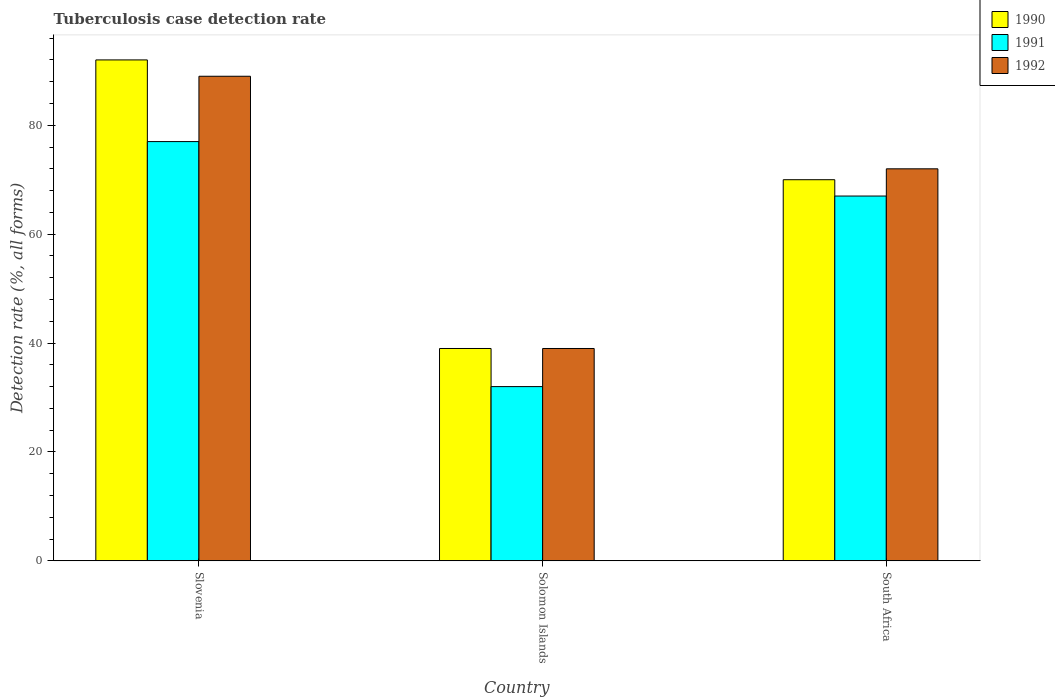How many groups of bars are there?
Offer a very short reply. 3. Are the number of bars per tick equal to the number of legend labels?
Provide a succinct answer. Yes. Are the number of bars on each tick of the X-axis equal?
Keep it short and to the point. Yes. How many bars are there on the 3rd tick from the right?
Your answer should be compact. 3. What is the label of the 3rd group of bars from the left?
Ensure brevity in your answer.  South Africa. In how many cases, is the number of bars for a given country not equal to the number of legend labels?
Give a very brief answer. 0. What is the tuberculosis case detection rate in in 1992 in Solomon Islands?
Offer a very short reply. 39. Across all countries, what is the maximum tuberculosis case detection rate in in 1992?
Give a very brief answer. 89. In which country was the tuberculosis case detection rate in in 1992 maximum?
Provide a succinct answer. Slovenia. In which country was the tuberculosis case detection rate in in 1992 minimum?
Provide a short and direct response. Solomon Islands. What is the total tuberculosis case detection rate in in 1991 in the graph?
Your response must be concise. 176. What is the difference between the tuberculosis case detection rate in in 1992 in Solomon Islands and that in South Africa?
Give a very brief answer. -33. What is the difference between the tuberculosis case detection rate in of/in 1990 and tuberculosis case detection rate in of/in 1992 in Slovenia?
Your answer should be compact. 3. What is the ratio of the tuberculosis case detection rate in in 1992 in Slovenia to that in South Africa?
Provide a succinct answer. 1.24. Is the tuberculosis case detection rate in in 1992 in Slovenia less than that in South Africa?
Offer a very short reply. No. What is the difference between the highest and the second highest tuberculosis case detection rate in in 1991?
Your answer should be very brief. -35. What does the 2nd bar from the left in Slovenia represents?
Provide a short and direct response. 1991. What does the 2nd bar from the right in South Africa represents?
Ensure brevity in your answer.  1991. Is it the case that in every country, the sum of the tuberculosis case detection rate in in 1991 and tuberculosis case detection rate in in 1990 is greater than the tuberculosis case detection rate in in 1992?
Offer a terse response. Yes. Are all the bars in the graph horizontal?
Offer a very short reply. No. Are the values on the major ticks of Y-axis written in scientific E-notation?
Offer a terse response. No. Does the graph contain grids?
Offer a very short reply. No. How many legend labels are there?
Your answer should be compact. 3. What is the title of the graph?
Offer a very short reply. Tuberculosis case detection rate. What is the label or title of the Y-axis?
Keep it short and to the point. Detection rate (%, all forms). What is the Detection rate (%, all forms) in 1990 in Slovenia?
Offer a terse response. 92. What is the Detection rate (%, all forms) of 1991 in Slovenia?
Offer a very short reply. 77. What is the Detection rate (%, all forms) of 1992 in Slovenia?
Your answer should be very brief. 89. What is the Detection rate (%, all forms) in 1990 in Solomon Islands?
Keep it short and to the point. 39. What is the Detection rate (%, all forms) of 1991 in Solomon Islands?
Your response must be concise. 32. What is the Detection rate (%, all forms) in 1990 in South Africa?
Your answer should be compact. 70. Across all countries, what is the maximum Detection rate (%, all forms) of 1990?
Keep it short and to the point. 92. Across all countries, what is the maximum Detection rate (%, all forms) of 1992?
Offer a very short reply. 89. Across all countries, what is the minimum Detection rate (%, all forms) in 1992?
Your answer should be compact. 39. What is the total Detection rate (%, all forms) of 1990 in the graph?
Keep it short and to the point. 201. What is the total Detection rate (%, all forms) of 1991 in the graph?
Make the answer very short. 176. What is the difference between the Detection rate (%, all forms) in 1991 in Slovenia and that in Solomon Islands?
Your answer should be compact. 45. What is the difference between the Detection rate (%, all forms) in 1992 in Slovenia and that in Solomon Islands?
Keep it short and to the point. 50. What is the difference between the Detection rate (%, all forms) in 1990 in Slovenia and that in South Africa?
Your response must be concise. 22. What is the difference between the Detection rate (%, all forms) of 1991 in Slovenia and that in South Africa?
Offer a terse response. 10. What is the difference between the Detection rate (%, all forms) in 1990 in Solomon Islands and that in South Africa?
Your response must be concise. -31. What is the difference between the Detection rate (%, all forms) in 1991 in Solomon Islands and that in South Africa?
Your answer should be compact. -35. What is the difference between the Detection rate (%, all forms) of 1992 in Solomon Islands and that in South Africa?
Give a very brief answer. -33. What is the difference between the Detection rate (%, all forms) in 1990 in Slovenia and the Detection rate (%, all forms) in 1991 in Solomon Islands?
Provide a succinct answer. 60. What is the difference between the Detection rate (%, all forms) in 1990 in Slovenia and the Detection rate (%, all forms) in 1991 in South Africa?
Give a very brief answer. 25. What is the difference between the Detection rate (%, all forms) in 1990 in Solomon Islands and the Detection rate (%, all forms) in 1991 in South Africa?
Your response must be concise. -28. What is the difference between the Detection rate (%, all forms) in 1990 in Solomon Islands and the Detection rate (%, all forms) in 1992 in South Africa?
Offer a very short reply. -33. What is the average Detection rate (%, all forms) of 1990 per country?
Give a very brief answer. 67. What is the average Detection rate (%, all forms) of 1991 per country?
Provide a short and direct response. 58.67. What is the average Detection rate (%, all forms) in 1992 per country?
Offer a very short reply. 66.67. What is the difference between the Detection rate (%, all forms) of 1990 and Detection rate (%, all forms) of 1991 in Slovenia?
Provide a succinct answer. 15. What is the difference between the Detection rate (%, all forms) in 1991 and Detection rate (%, all forms) in 1992 in Slovenia?
Provide a succinct answer. -12. What is the difference between the Detection rate (%, all forms) in 1990 and Detection rate (%, all forms) in 1991 in Solomon Islands?
Offer a very short reply. 7. What is the difference between the Detection rate (%, all forms) in 1991 and Detection rate (%, all forms) in 1992 in South Africa?
Ensure brevity in your answer.  -5. What is the ratio of the Detection rate (%, all forms) of 1990 in Slovenia to that in Solomon Islands?
Provide a short and direct response. 2.36. What is the ratio of the Detection rate (%, all forms) of 1991 in Slovenia to that in Solomon Islands?
Offer a very short reply. 2.41. What is the ratio of the Detection rate (%, all forms) of 1992 in Slovenia to that in Solomon Islands?
Make the answer very short. 2.28. What is the ratio of the Detection rate (%, all forms) in 1990 in Slovenia to that in South Africa?
Provide a short and direct response. 1.31. What is the ratio of the Detection rate (%, all forms) of 1991 in Slovenia to that in South Africa?
Make the answer very short. 1.15. What is the ratio of the Detection rate (%, all forms) in 1992 in Slovenia to that in South Africa?
Ensure brevity in your answer.  1.24. What is the ratio of the Detection rate (%, all forms) in 1990 in Solomon Islands to that in South Africa?
Keep it short and to the point. 0.56. What is the ratio of the Detection rate (%, all forms) in 1991 in Solomon Islands to that in South Africa?
Your response must be concise. 0.48. What is the ratio of the Detection rate (%, all forms) of 1992 in Solomon Islands to that in South Africa?
Keep it short and to the point. 0.54. What is the difference between the highest and the second highest Detection rate (%, all forms) in 1992?
Make the answer very short. 17. What is the difference between the highest and the lowest Detection rate (%, all forms) of 1990?
Make the answer very short. 53. What is the difference between the highest and the lowest Detection rate (%, all forms) of 1991?
Your answer should be very brief. 45. What is the difference between the highest and the lowest Detection rate (%, all forms) in 1992?
Provide a succinct answer. 50. 